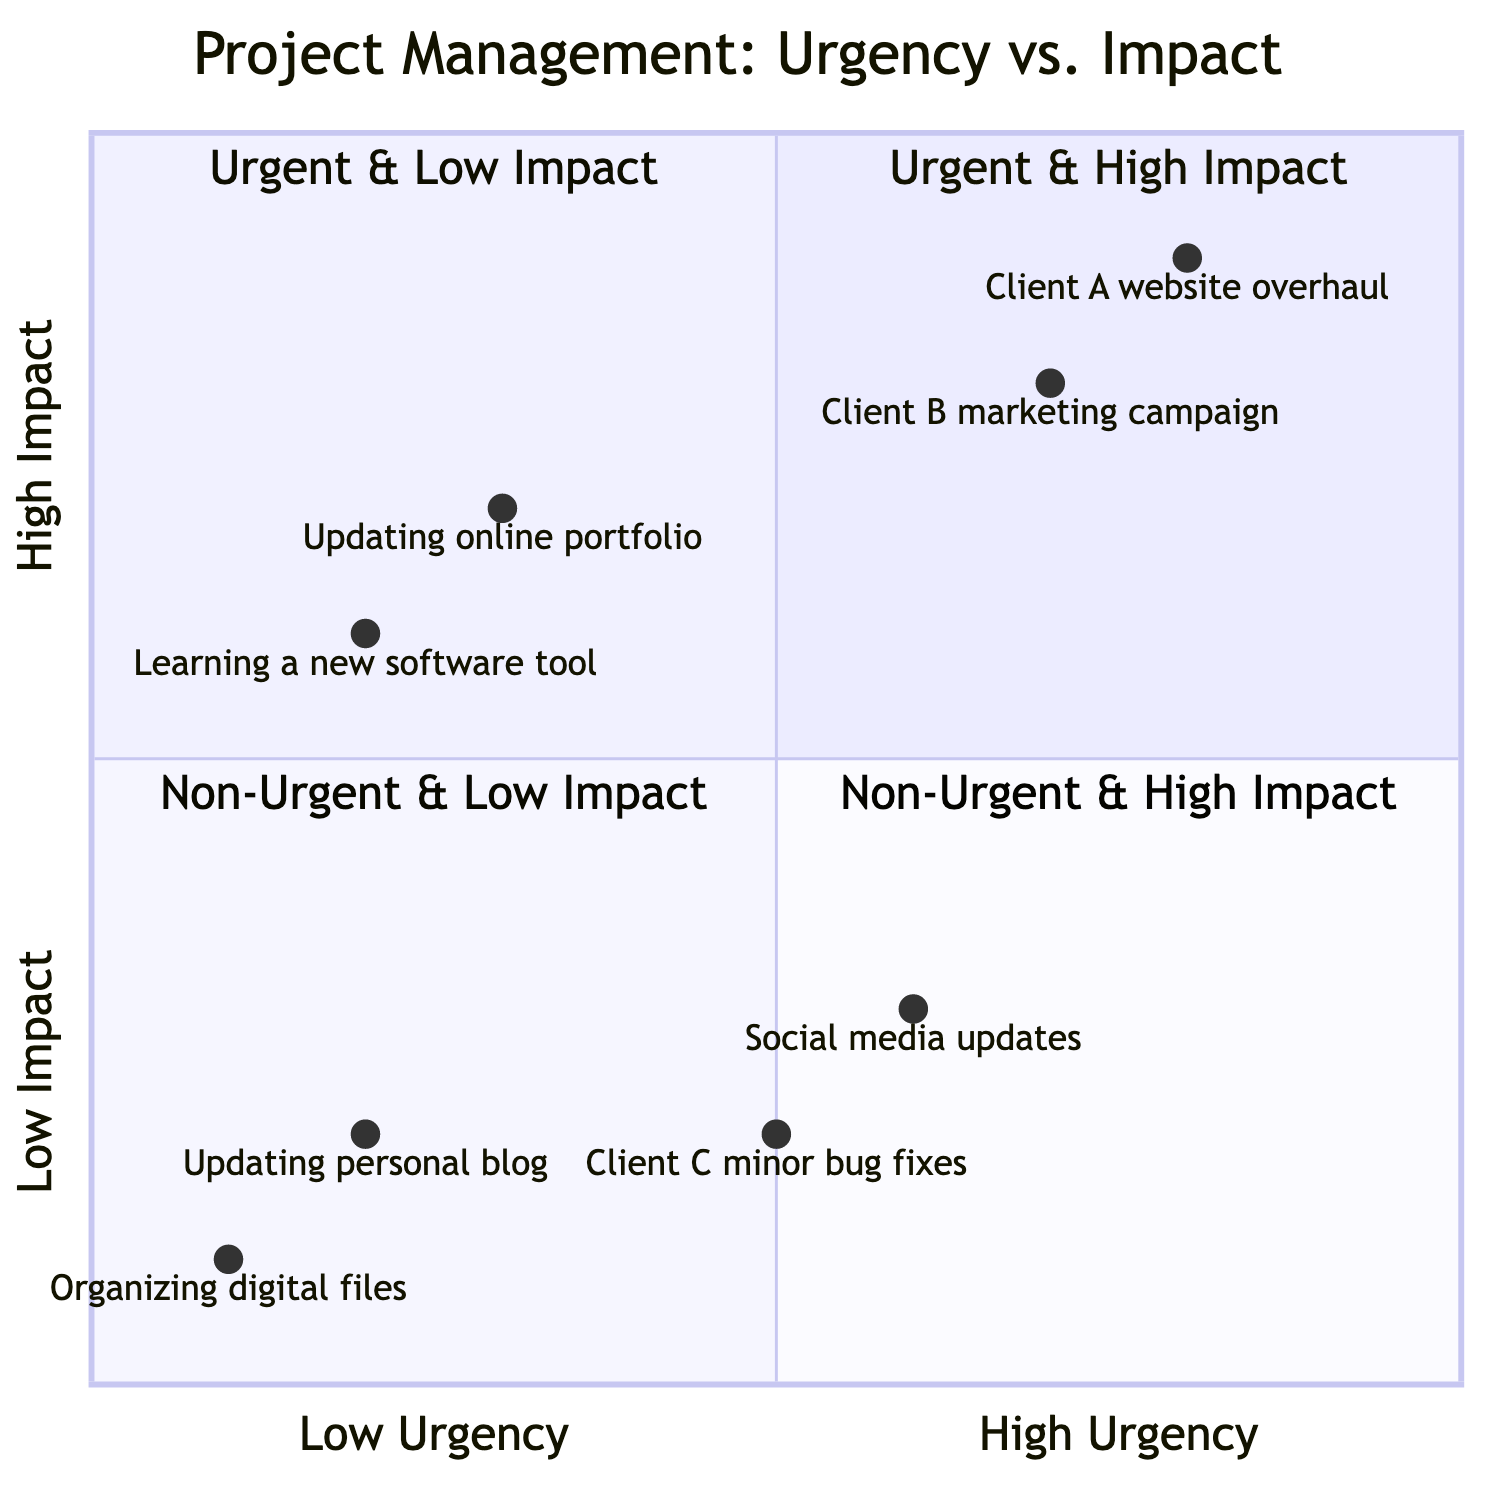What are the projects categorized as urgent and high impact? The quadrant for urgent and high impact projects includes "Client A website overhaul" and "Client B marketing campaign."
Answer: Client A website overhaul, Client B marketing campaign How many projects are categorized as non-urgent and low impact? In the non-urgent and low impact quadrant, there are two projects: "Organizing digital files" and "Updating personal blog." Hence, the total is two.
Answer: 2 Which project has the lowest urgency and is categorized as high impact? The quadrant for non-urgent and high impact has the project "Updating online portfolio," which has the lowest urgency in that category.
Answer: Updating online portfolio What is the relationship between urgency and impact for "Social media updates"? "Social media updates" is placed in the urgent and low impact quadrant, indicating it is time-sensitive but does not have significant impact.
Answer: Urgent & Low Impact How many total projects are represented in the diagram? There are eight projects listed across the quadrants: two in urgent high impact, two in urgent low impact, two in non-urgent high impact, and two in non-urgent low impact. Adding them gives a total of eight.
Answer: 8 Which project has the highest urgency in the diagram? The highest urgency project is "Client A website overhaul," being in the urgent and high impact quadrant with a high urgency score.
Answer: Client A website overhaul How do "Learning a new software tool" and "Client C minor bug fixes" compare in terms of impact? "Learning a new software tool" is categorized as non-urgent and high impact while "Client C minor bug fixes" is categorized as urgent and low impact; hence the former has a higher impact despite being non-urgent.
Answer: Learning a new software tool What quadrant would "Client B marketing campaign" fall into? "Client B marketing campaign” is in the quadrant representing urgent and high impact due to its priority and significance.
Answer: Urgent & High Impact 